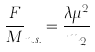<formula> <loc_0><loc_0><loc_500><loc_500>\frac { F } { M } _ { n . s . } = \frac { \lambda \mu ^ { 2 } } { m _ { 2 } }</formula> 